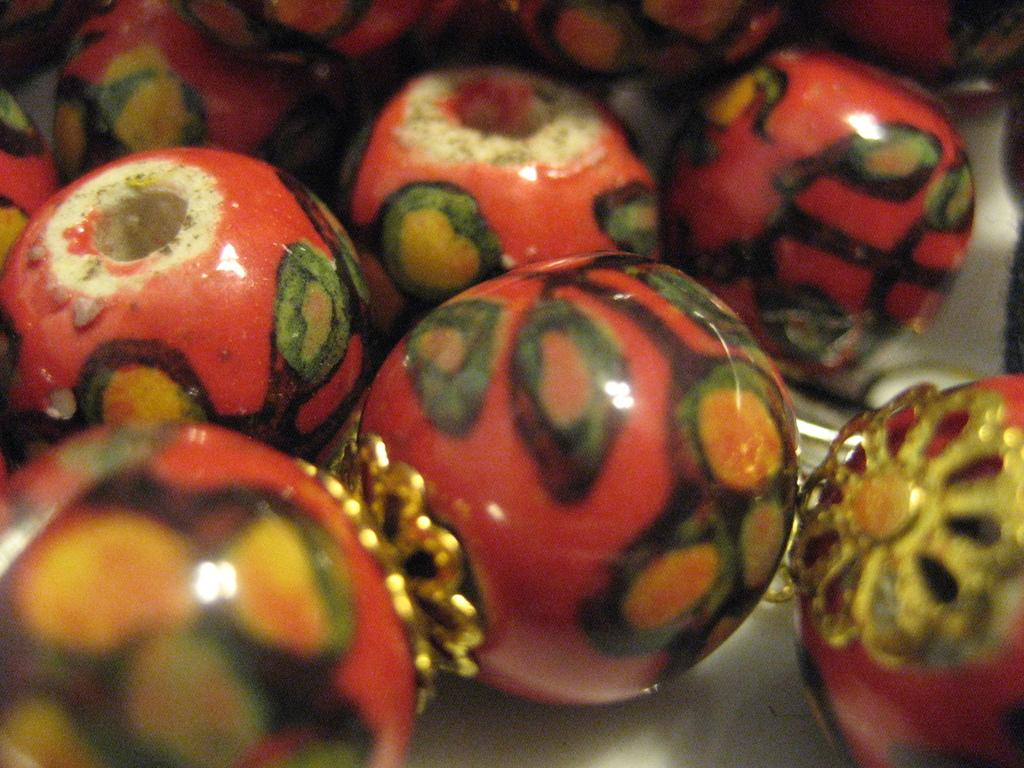What objects are present in the image? There are beads in the image. Can you describe the appearance of the beads? The beads may vary in size, shape, and color, but they are small, round, or oval objects. How are the beads arranged or positioned in the image? The arrangement of the beads cannot be determined without more information, but they are likely grouped or scattered in some way. What type of mass is being measured by the owl in the image? There is no owl present in the image, and therefore no mass can be measured by an owl. 